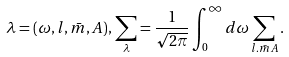Convert formula to latex. <formula><loc_0><loc_0><loc_500><loc_500>\lambda = ( \omega , l , \bar { m } , A ) , \, \sum _ { \lambda } = \frac { 1 } { \sqrt { 2 \pi } } \int ^ { \infty } _ { 0 } d \omega \sum _ { l . \bar { m } A } .</formula> 